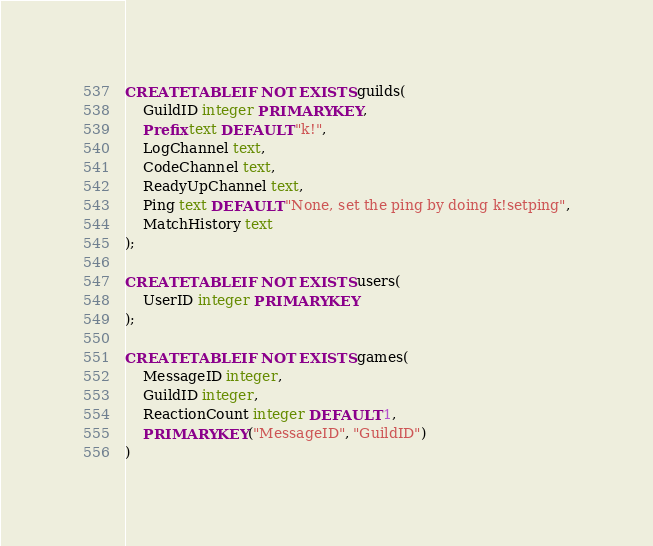<code> <loc_0><loc_0><loc_500><loc_500><_SQL_>CREATE TABLE IF NOT EXISTS guilds(
    GuildID integer PRIMARY KEY,
    Prefix text DEFAULT "k!",
    LogChannel text,
    CodeChannel text,
    ReadyUpChannel text,
    Ping text DEFAULT "None, set the ping by doing k!setping",
    MatchHistory text
);

CREATE TABLE IF NOT EXISTS users(
    UserID integer PRIMARY KEY
);

CREATE TABLE IF NOT EXISTS games(
    MessageID integer,
    GuildID integer,
    ReactionCount integer DEFAULT 1,
    PRIMARY KEY("MessageID", "GuildID")
)</code> 